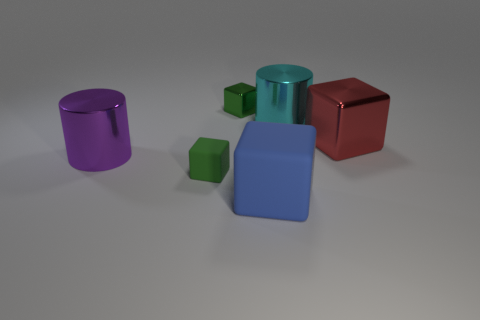There is a matte object that is the same color as the small metallic cube; what is its shape?
Provide a succinct answer. Cube. Does the red object that is on the right side of the green matte block have the same shape as the cyan object?
Provide a short and direct response. No. The tiny thing that is the same material as the large purple object is what color?
Offer a very short reply. Green. Are there any large cyan metal cylinders in front of the tiny object on the right side of the matte object on the left side of the green metal thing?
Give a very brief answer. Yes. What is the shape of the purple metal thing?
Offer a terse response. Cylinder. Are there fewer purple objects behind the small metallic block than small purple rubber cylinders?
Provide a short and direct response. No. Are there any small green metallic things that have the same shape as the blue rubber thing?
Ensure brevity in your answer.  Yes. The purple shiny thing that is the same size as the cyan metallic cylinder is what shape?
Your answer should be compact. Cylinder. What number of objects are either big red cubes or big rubber blocks?
Your response must be concise. 2. Are any big cyan metallic cylinders visible?
Your answer should be very brief. Yes. 